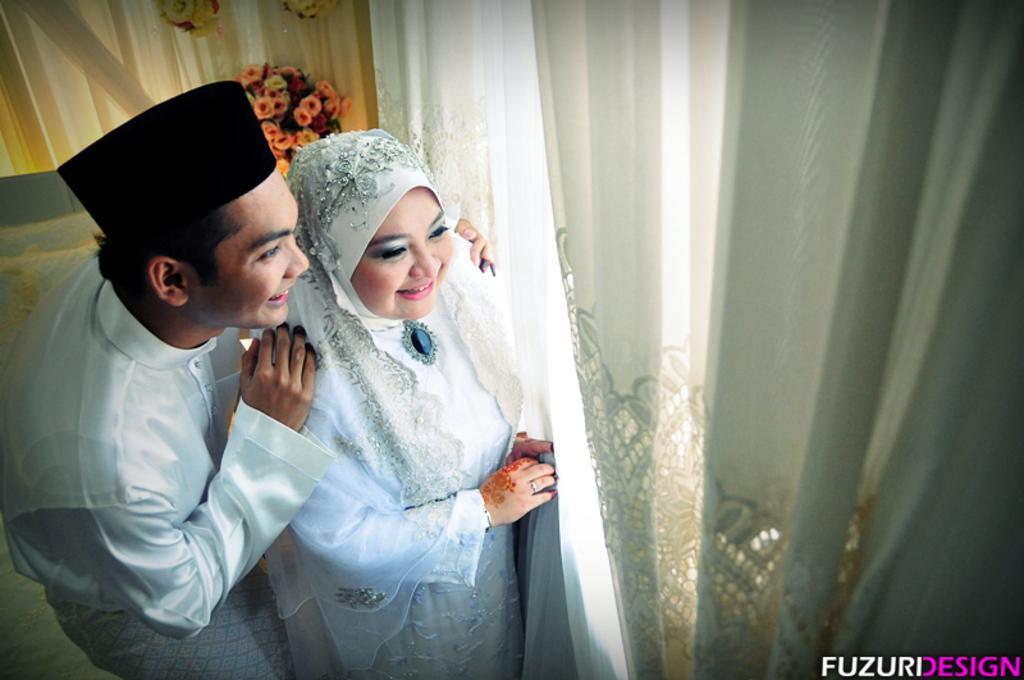How would you summarize this image in a sentence or two? In this picture there is a boy and a girl on the left side of the image in front of a curtain and there are flowers and curtains in the background area of the image. 